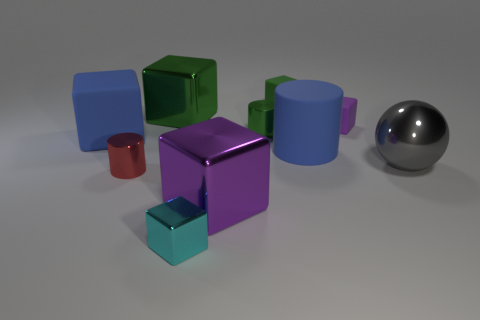Subtract all cyan cubes. How many cubes are left? 5 Subtract 3 cubes. How many cubes are left? 3 Subtract all big purple shiny blocks. How many blocks are left? 5 Subtract all yellow blocks. Subtract all brown cylinders. How many blocks are left? 6 Subtract all cubes. How many objects are left? 4 Add 5 big shiny objects. How many big shiny objects are left? 8 Add 4 big cylinders. How many big cylinders exist? 5 Subtract 0 brown cylinders. How many objects are left? 10 Subtract all tiny green metal cylinders. Subtract all blue cylinders. How many objects are left? 8 